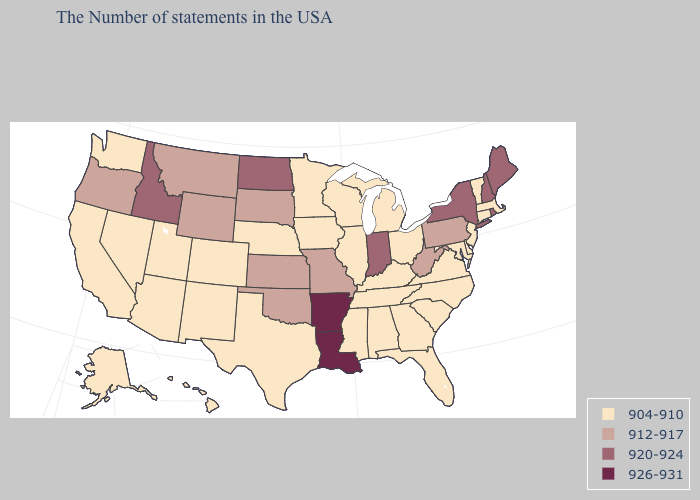What is the value of Mississippi?
Quick response, please. 904-910. Does the map have missing data?
Be succinct. No. What is the value of Nebraska?
Short answer required. 904-910. Does the map have missing data?
Be succinct. No. Among the states that border Tennessee , does Arkansas have the highest value?
Quick response, please. Yes. Which states have the lowest value in the USA?
Answer briefly. Massachusetts, Vermont, Connecticut, New Jersey, Delaware, Maryland, Virginia, North Carolina, South Carolina, Ohio, Florida, Georgia, Michigan, Kentucky, Alabama, Tennessee, Wisconsin, Illinois, Mississippi, Minnesota, Iowa, Nebraska, Texas, Colorado, New Mexico, Utah, Arizona, Nevada, California, Washington, Alaska, Hawaii. What is the value of Pennsylvania?
Give a very brief answer. 912-917. What is the value of Missouri?
Give a very brief answer. 912-917. What is the value of West Virginia?
Short answer required. 912-917. Does Louisiana have the lowest value in the South?
Quick response, please. No. Among the states that border Massachusetts , does Rhode Island have the highest value?
Short answer required. Yes. Does Pennsylvania have a higher value than Indiana?
Keep it brief. No. What is the value of West Virginia?
Short answer required. 912-917. Name the states that have a value in the range 926-931?
Concise answer only. Louisiana, Arkansas. What is the value of Kansas?
Keep it brief. 912-917. 